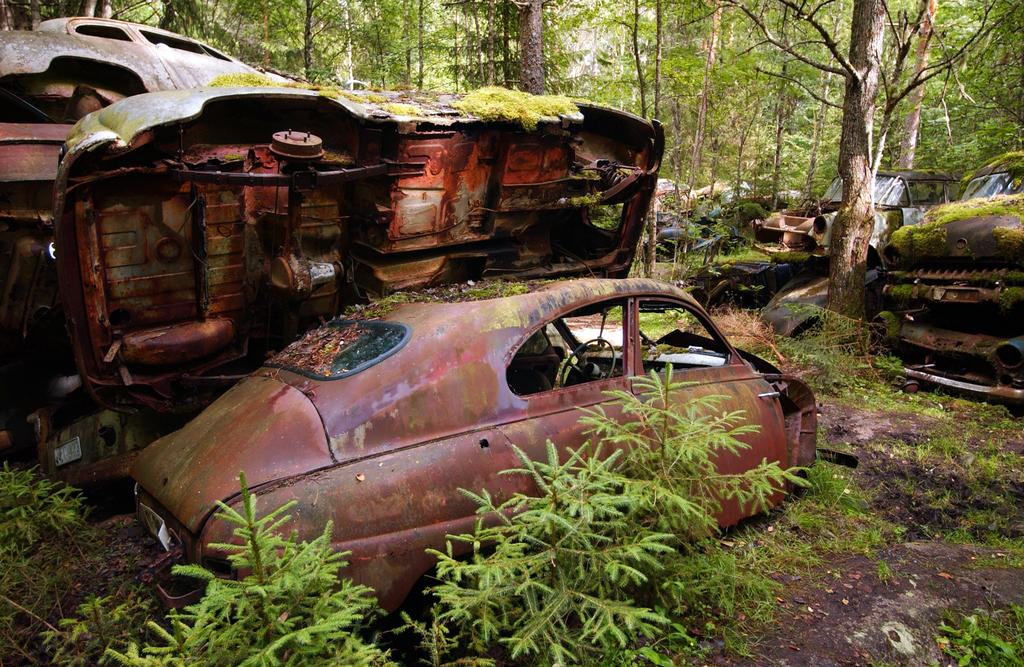What type of vehicles can be seen in the image? There are damaged cars in the image. Where are the damaged cars located in the image? The damaged cars are in the middle of the image. What type of vegetation is at the bottom of the image? There are plants at the bottom of the image. What type of vegetation can be seen at the top of the image? There are trees at the top of the image. What type of stew is being served on the shelf in the image? There is no stew or shelf present in the image. Can you see anyone wearing a mask in the image? There is no mask or person wearing a mask present in the image. 